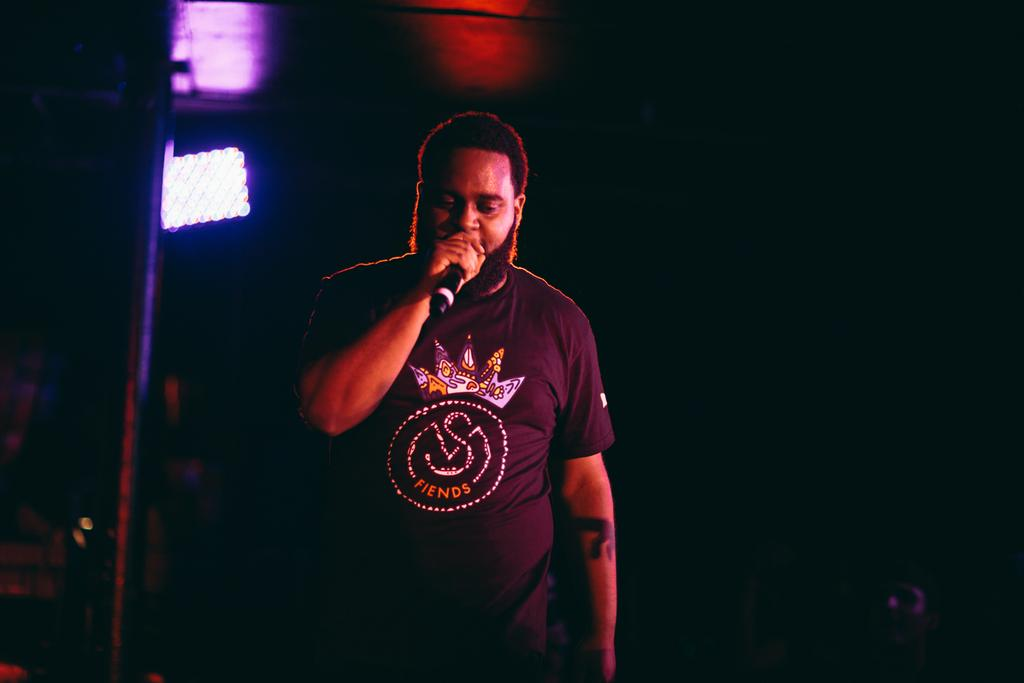What is the person in the image holding? The person is holding a mic in the image. What can be seen on the left side of the image? There is a pole and a light on the left side of the image. How would you describe the overall lighting in the image? The background of the image is dark. What is the condition of the hall in the image? There is no hall present in the image; it only features a person holding a mic, a pole, a light, and a dark background. 